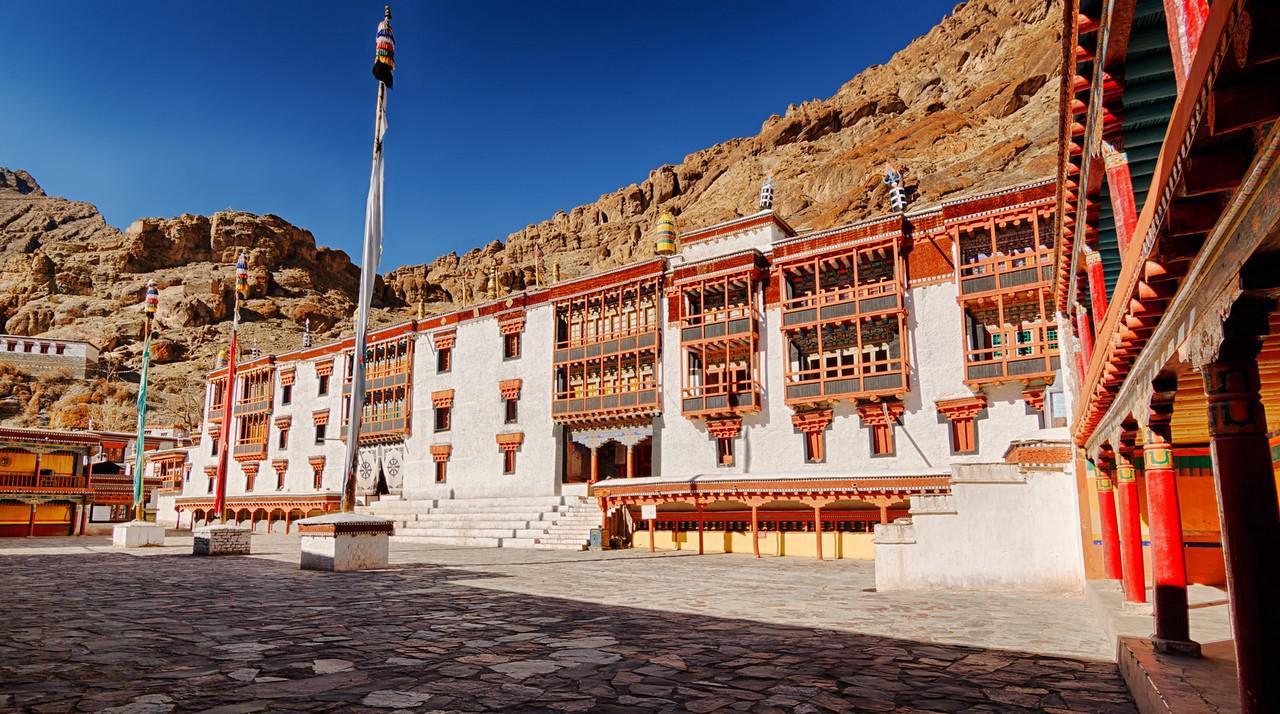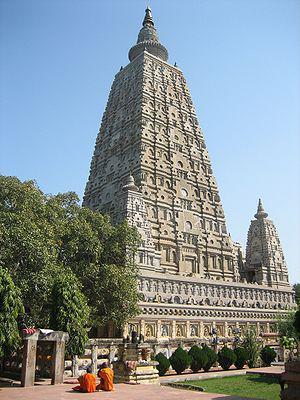The first image is the image on the left, the second image is the image on the right. Analyze the images presented: Is the assertion "One building has gray stone material, the other does not." valid? Answer yes or no. Yes. 